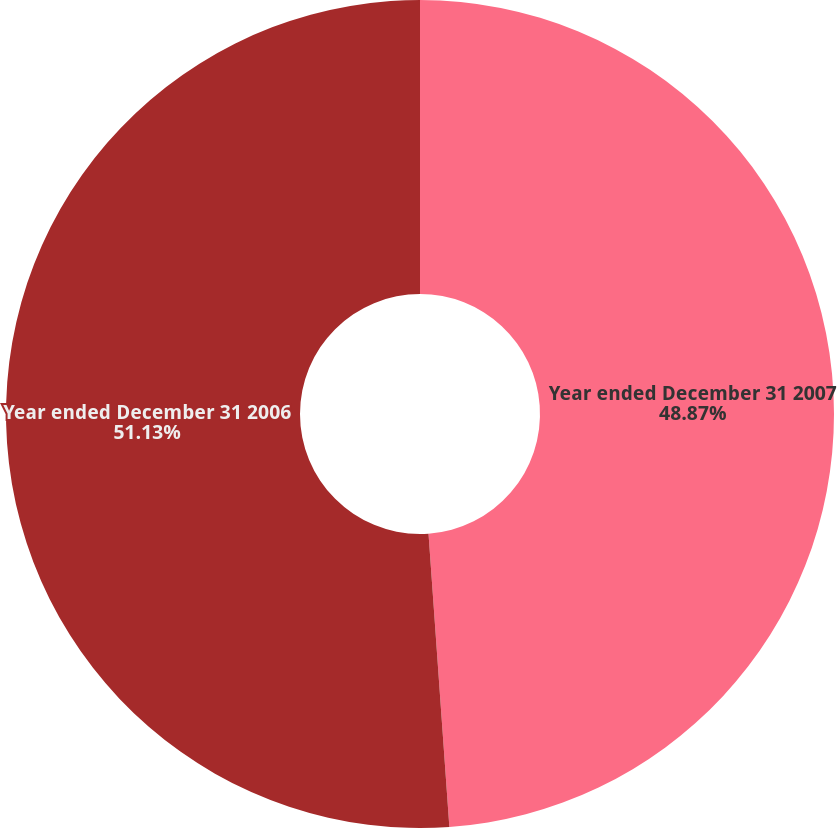Convert chart to OTSL. <chart><loc_0><loc_0><loc_500><loc_500><pie_chart><fcel>Year ended December 31 2007<fcel>Year ended December 31 2006<nl><fcel>48.87%<fcel>51.13%<nl></chart> 